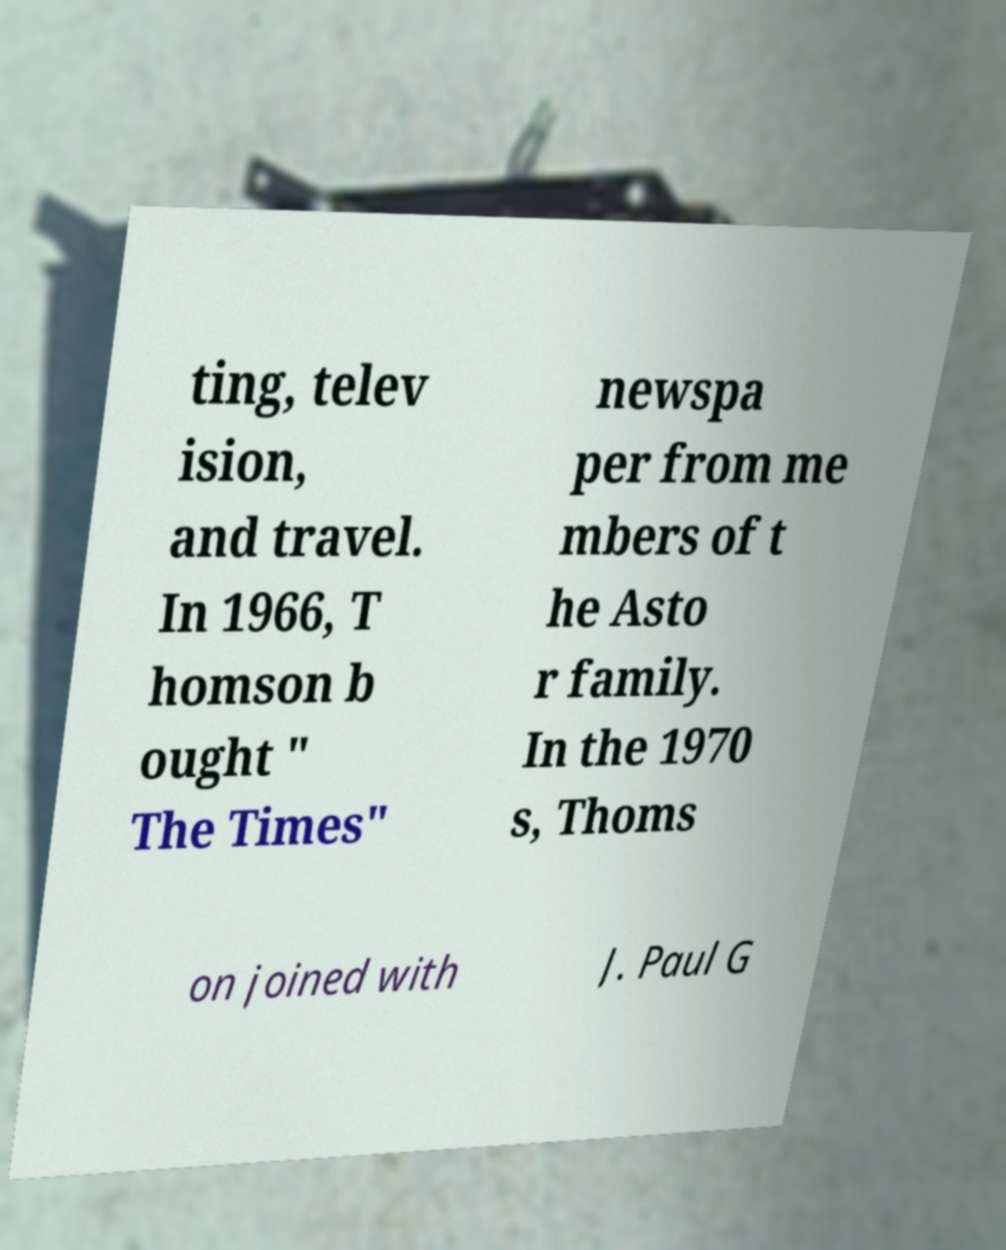Can you accurately transcribe the text from the provided image for me? ting, telev ision, and travel. In 1966, T homson b ought " The Times" newspa per from me mbers of t he Asto r family. In the 1970 s, Thoms on joined with J. Paul G 